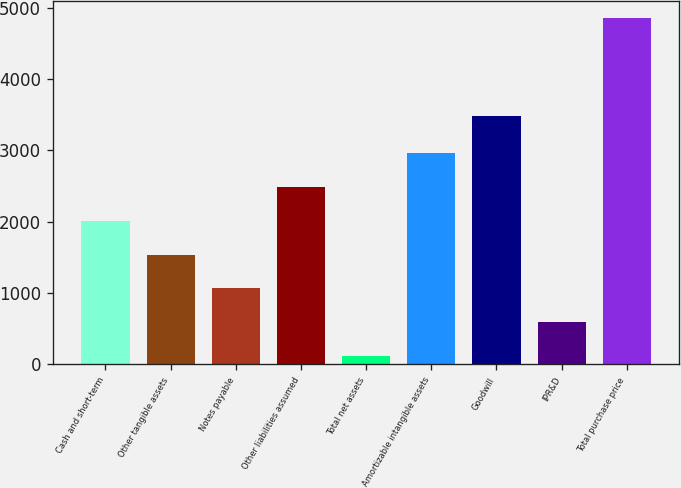Convert chart to OTSL. <chart><loc_0><loc_0><loc_500><loc_500><bar_chart><fcel>Cash and short-term<fcel>Other tangible assets<fcel>Notes payable<fcel>Other liabilities assumed<fcel>Total net assets<fcel>Amortizable intangible assets<fcel>Goodwill<fcel>IPR&D<fcel>Total purchase price<nl><fcel>2010<fcel>1536<fcel>1062<fcel>2484<fcel>114<fcel>2958<fcel>3480<fcel>588<fcel>4854<nl></chart> 